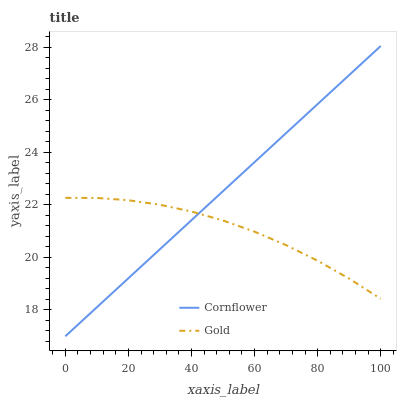Does Gold have the minimum area under the curve?
Answer yes or no. Yes. Does Cornflower have the maximum area under the curve?
Answer yes or no. Yes. Does Gold have the maximum area under the curve?
Answer yes or no. No. Is Cornflower the smoothest?
Answer yes or no. Yes. Is Gold the roughest?
Answer yes or no. Yes. Is Gold the smoothest?
Answer yes or no. No. Does Cornflower have the lowest value?
Answer yes or no. Yes. Does Gold have the lowest value?
Answer yes or no. No. Does Cornflower have the highest value?
Answer yes or no. Yes. Does Gold have the highest value?
Answer yes or no. No. Does Cornflower intersect Gold?
Answer yes or no. Yes. Is Cornflower less than Gold?
Answer yes or no. No. Is Cornflower greater than Gold?
Answer yes or no. No. 